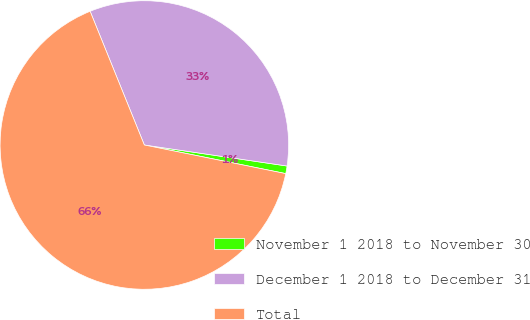<chart> <loc_0><loc_0><loc_500><loc_500><pie_chart><fcel>November 1 2018 to November 30<fcel>December 1 2018 to December 31<fcel>Total<nl><fcel>0.85%<fcel>33.46%<fcel>65.69%<nl></chart> 